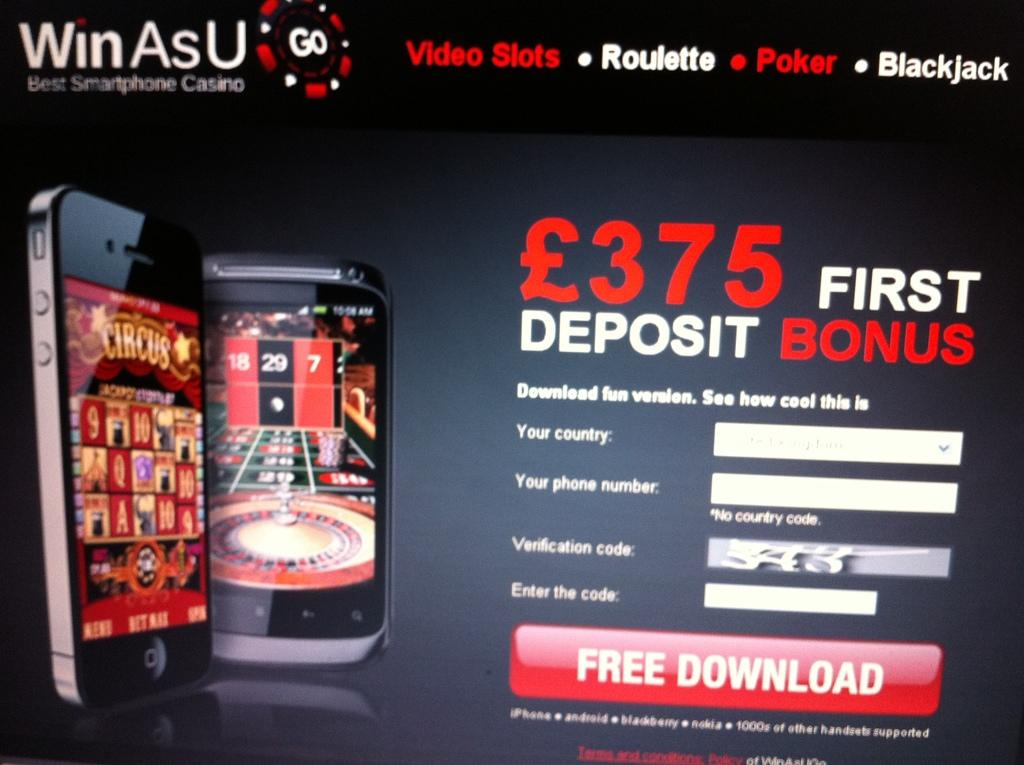<image>
Write a terse but informative summary of the picture. Ad for a phone app that saids $375 for the first deposit bonus. 